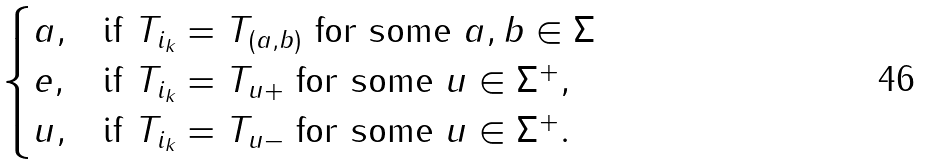<formula> <loc_0><loc_0><loc_500><loc_500>\begin{cases} a , & \text {if} \ T _ { i _ { k } } = T _ { ( a , b ) } \ \text {for some} \ a , b \in \Sigma \\ e , & \text {if} \ T _ { i _ { k } } = T _ { u + } \ \text {for some} \ u \in \Sigma ^ { + } , \\ u , & \text {if} \ T _ { i _ { k } } = T _ { u - } \ \text {for some} \ u \in \Sigma ^ { + } . \end{cases}</formula> 